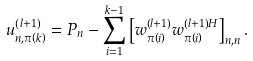Convert formula to latex. <formula><loc_0><loc_0><loc_500><loc_500>u _ { n , \pi \left ( k \right ) } ^ { \left ( l + 1 \right ) } = P _ { n } - \sum _ { i = 1 } ^ { k - 1 } \left [ w _ { \pi \left ( i \right ) } ^ { \left ( l + 1 \right ) } w _ { \pi \left ( i \right ) } ^ { \left ( l + 1 \right ) H } \right ] _ { n , n } .</formula> 